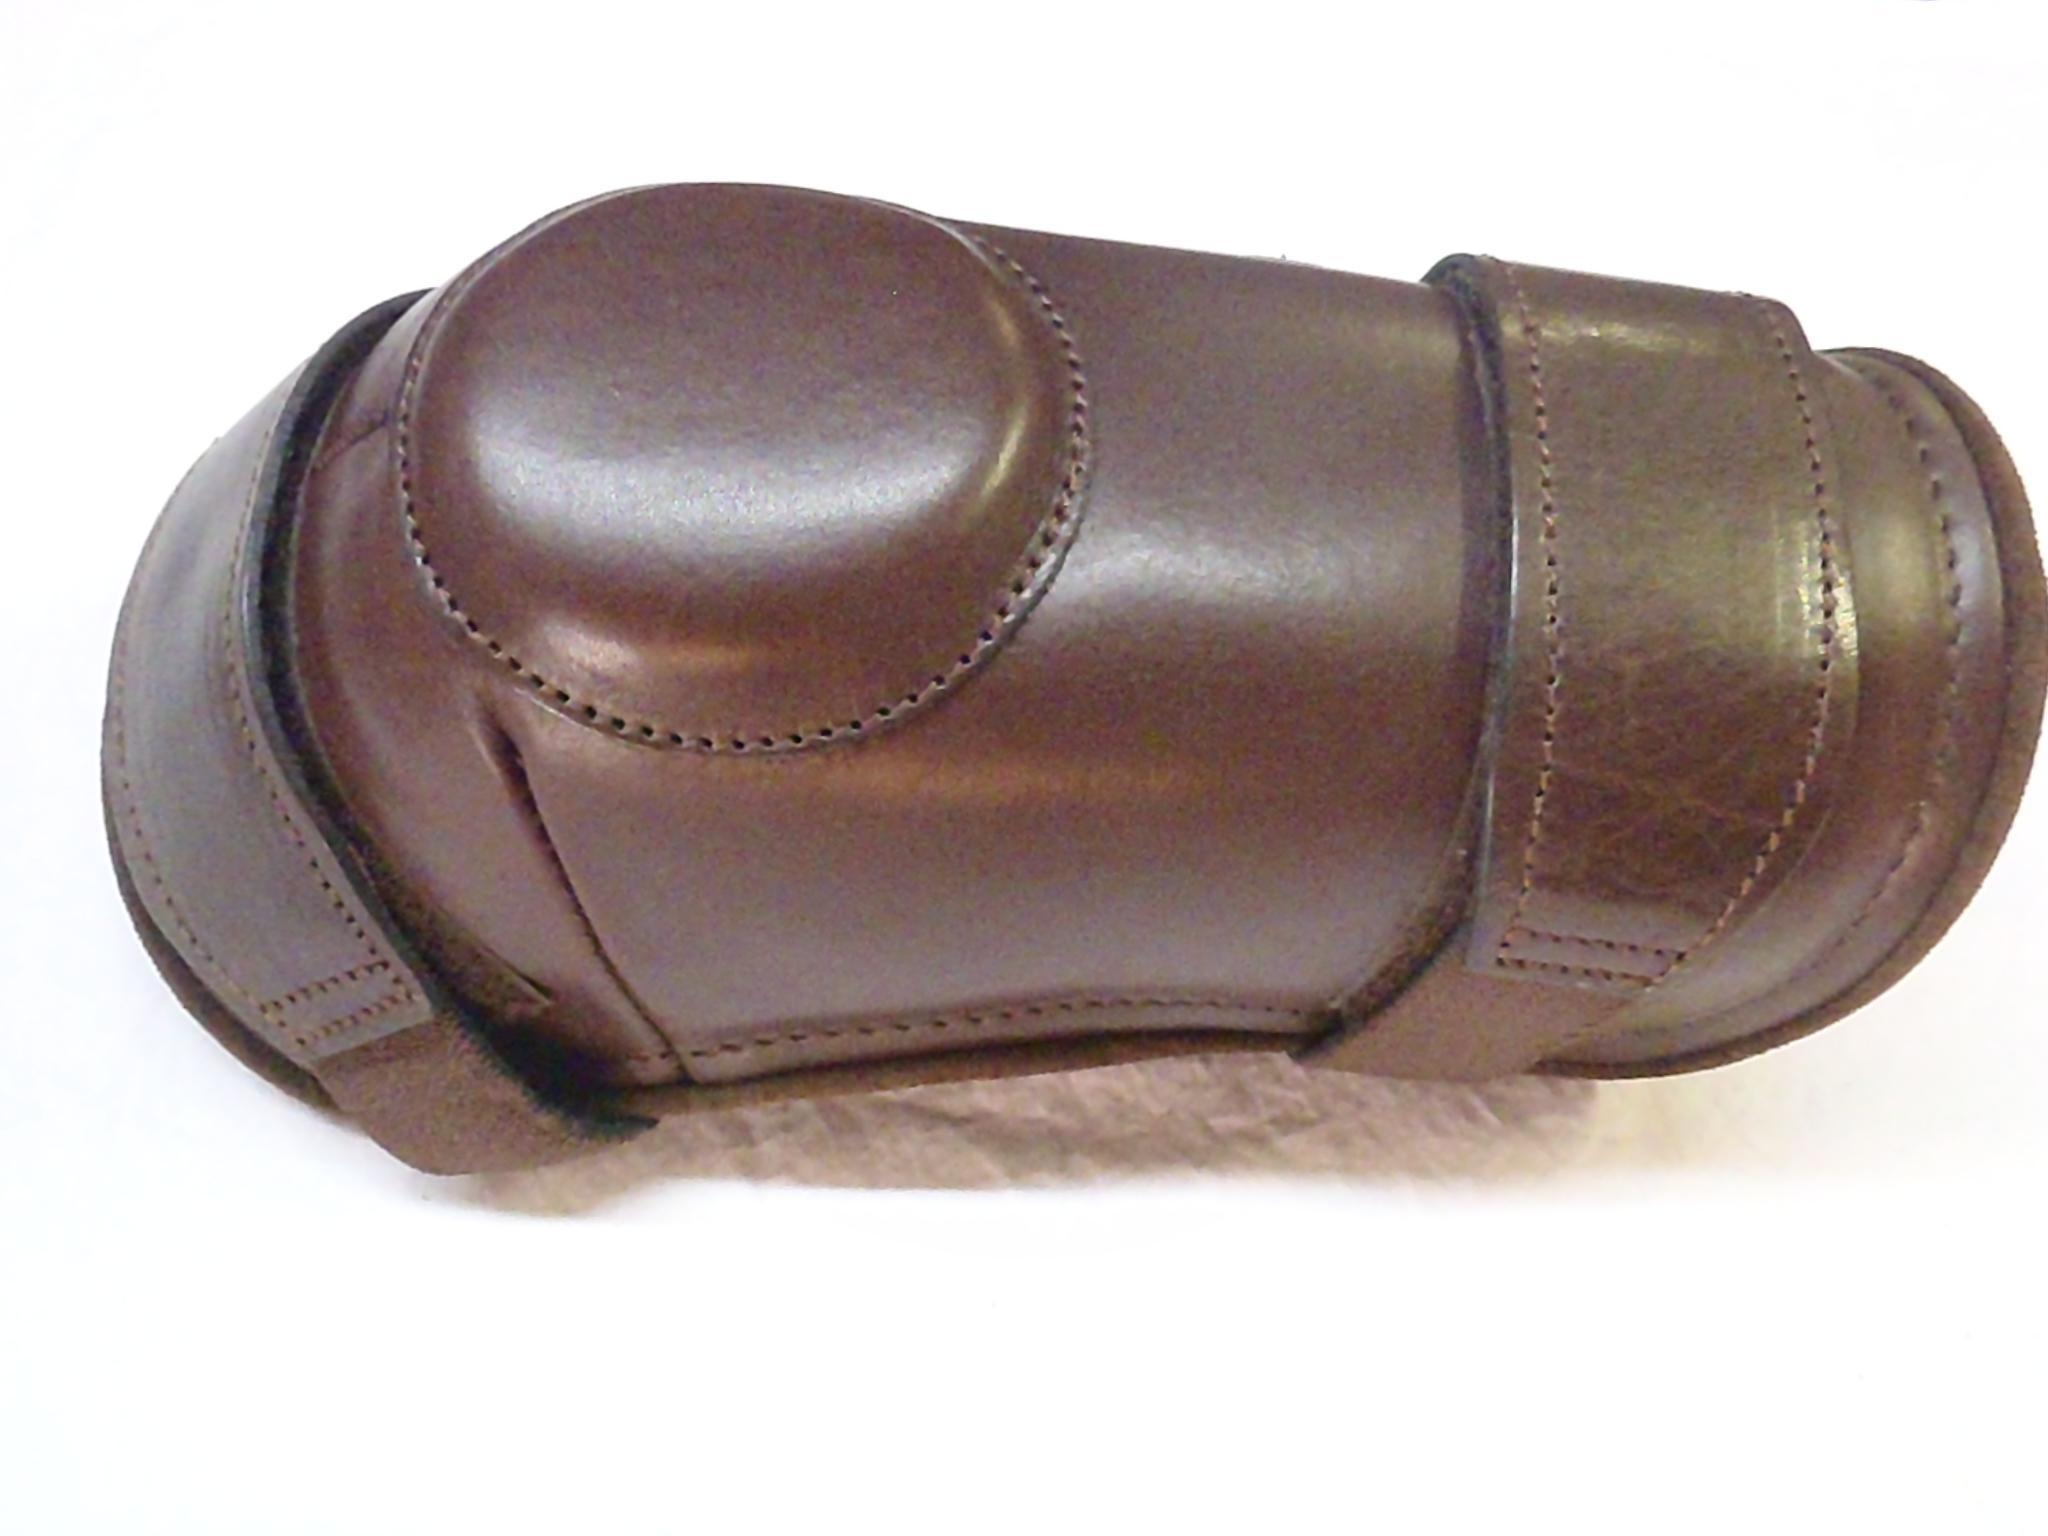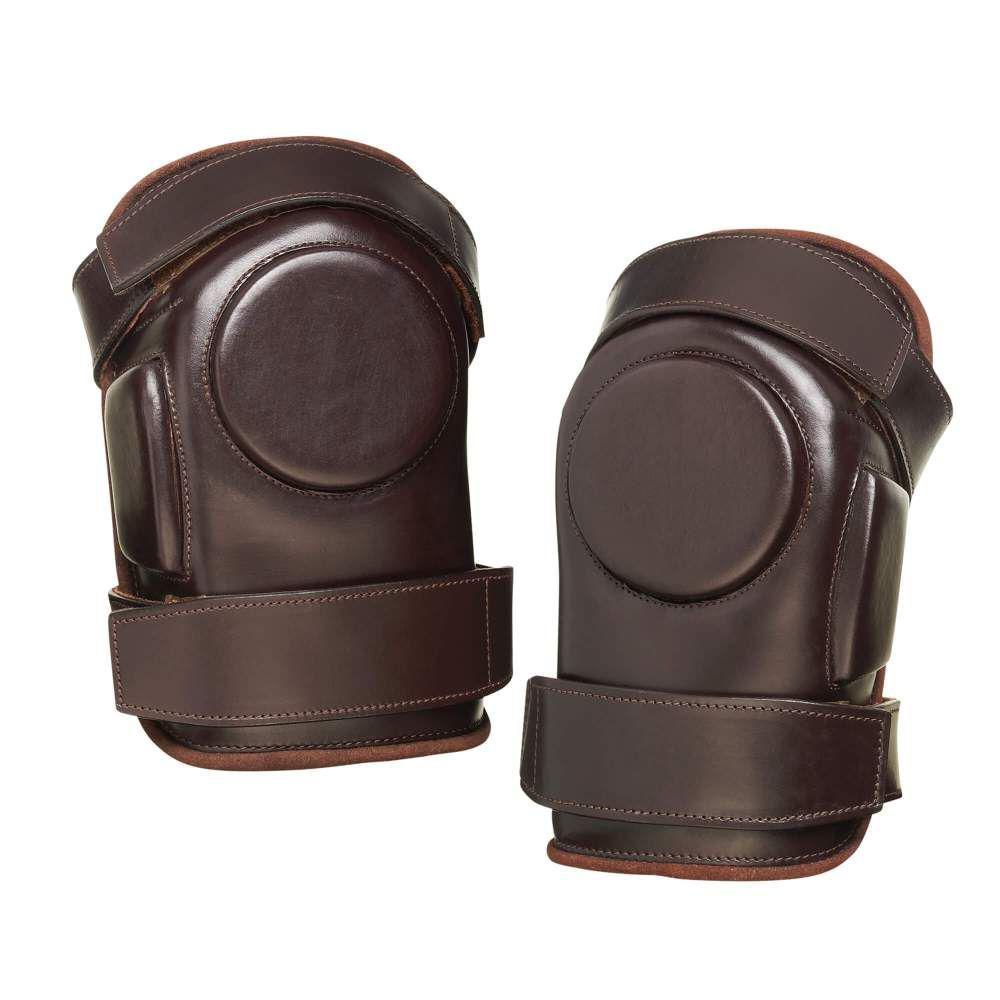The first image is the image on the left, the second image is the image on the right. For the images shown, is this caption "The number of protective items are not an even number; it is an odd number." true? Answer yes or no. Yes. 